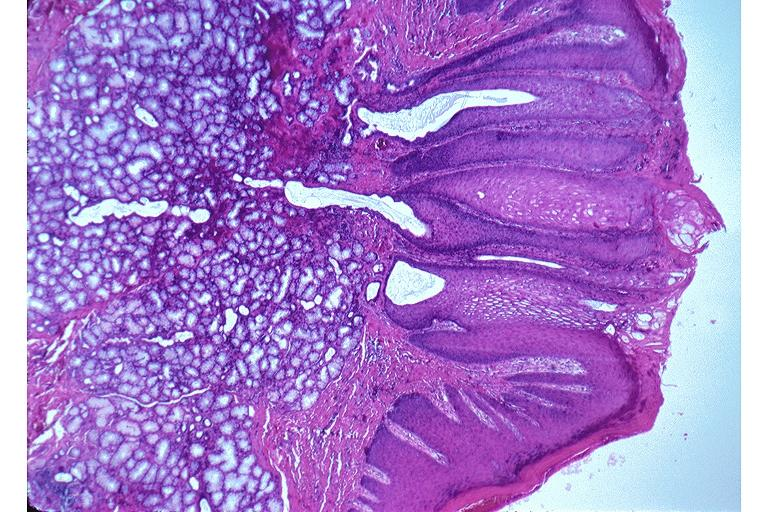s serous cystadenoma present?
Answer the question using a single word or phrase. No 